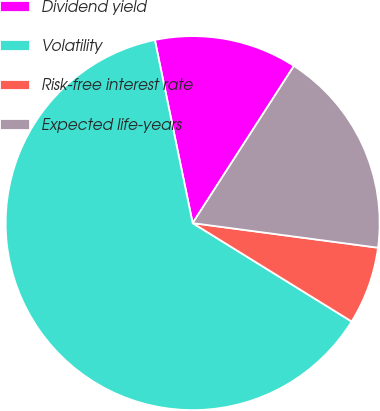Convert chart to OTSL. <chart><loc_0><loc_0><loc_500><loc_500><pie_chart><fcel>Dividend yield<fcel>Volatility<fcel>Risk-free interest rate<fcel>Expected life-years<nl><fcel>12.35%<fcel>62.94%<fcel>6.72%<fcel>17.99%<nl></chart> 